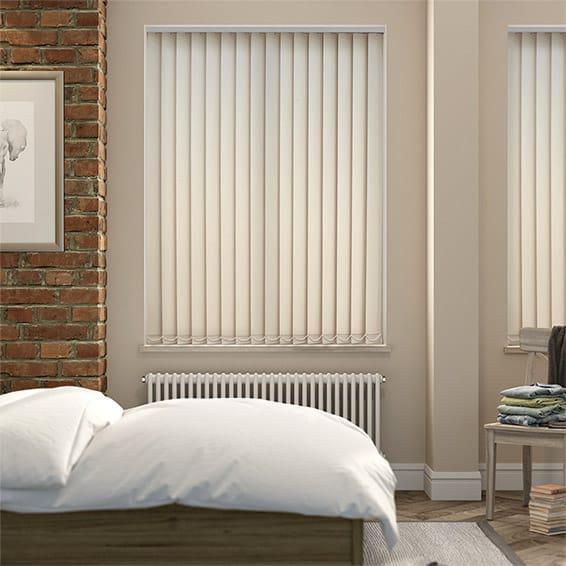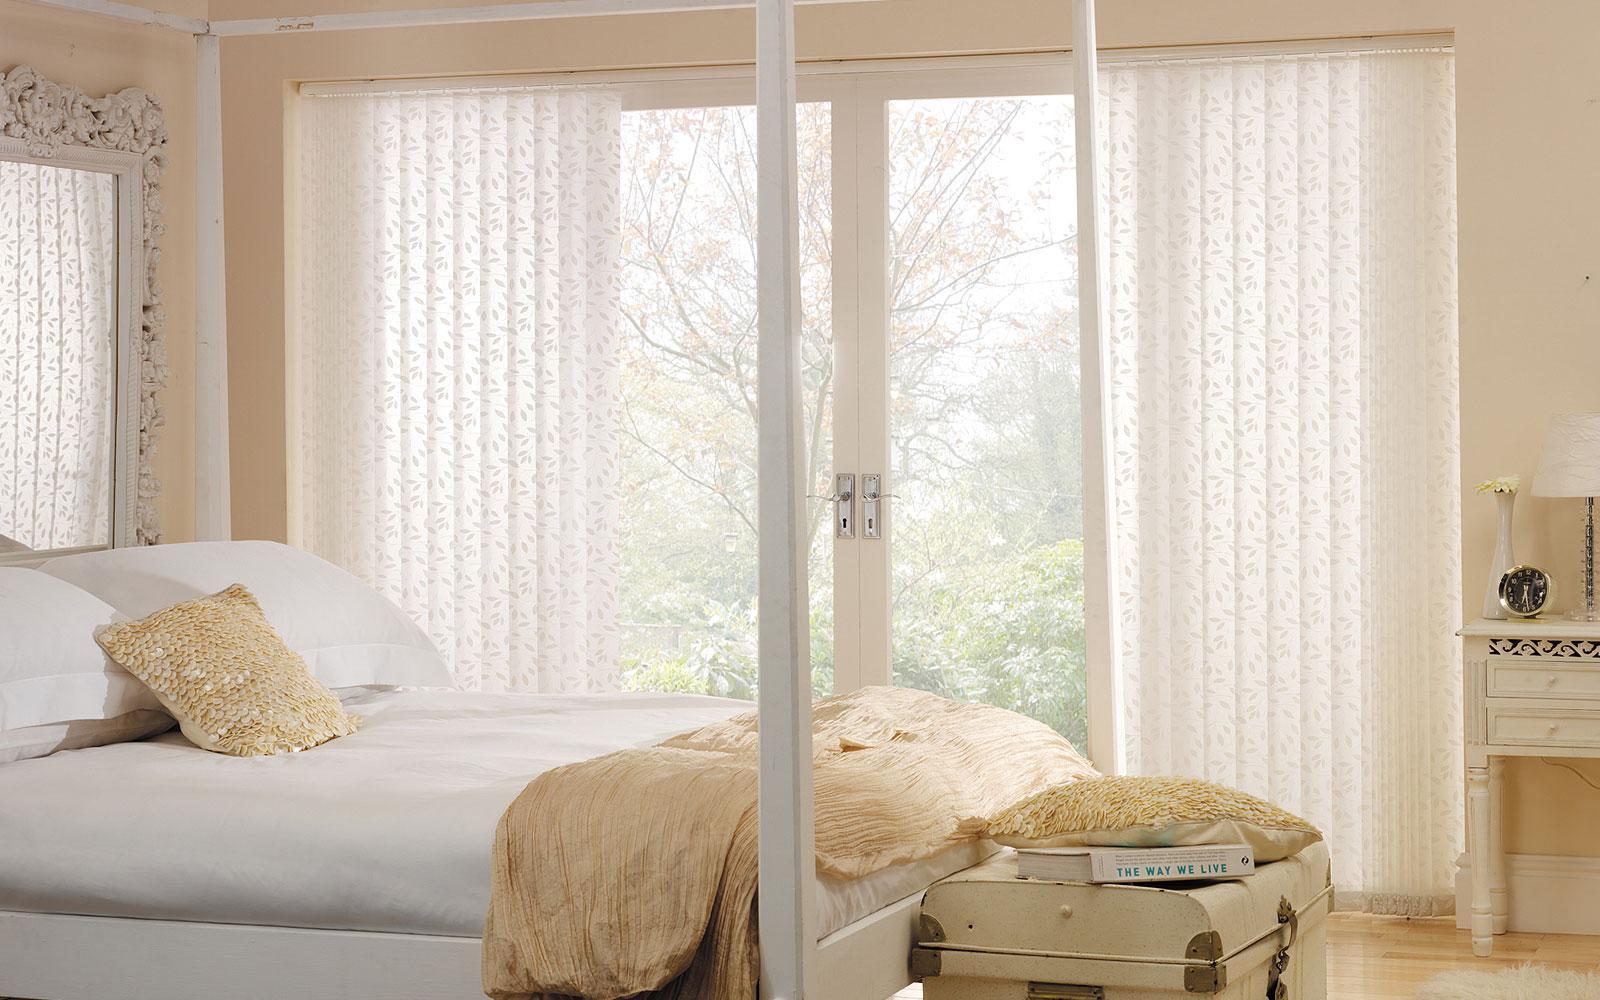The first image is the image on the left, the second image is the image on the right. Analyze the images presented: Is the assertion "There is a sofa/chair near the tall window, in the left image." valid? Answer yes or no. No. The first image is the image on the left, the second image is the image on the right. Evaluate the accuracy of this statement regarding the images: "There are two beds (any part of a bed) in front of whitish blinds.". Is it true? Answer yes or no. Yes. 